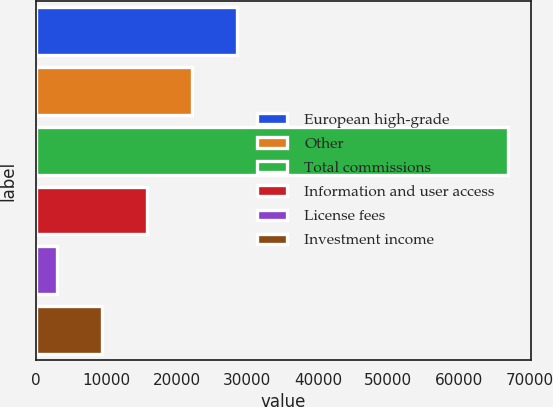<chart> <loc_0><loc_0><loc_500><loc_500><bar_chart><fcel>European high-grade<fcel>Other<fcel>Total commissions<fcel>Information and user access<fcel>License fees<fcel>Investment income<nl><fcel>28560<fcel>22167<fcel>66918<fcel>15774<fcel>2988<fcel>9381<nl></chart> 